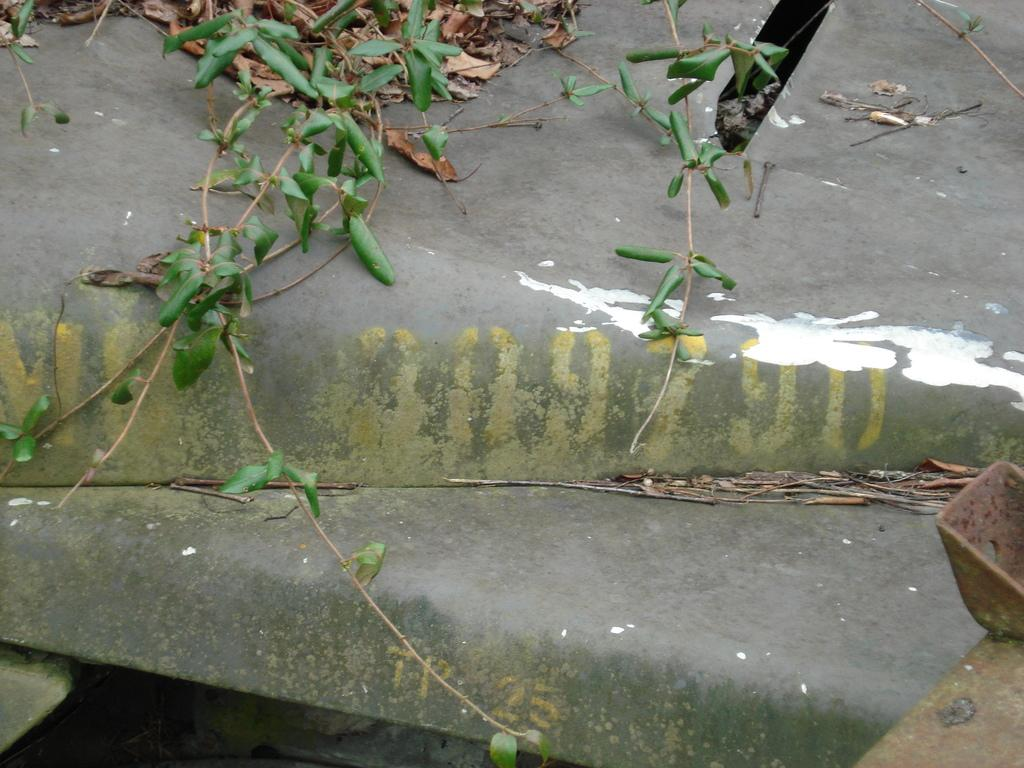What type of living organisms can be seen in the image? Plants can be seen in the image. What part of the plant is visible in the image? Leaves are visible in the image. What type of animal can be seen interacting with the plants in the image? There is no animal present in the image; it only features plants and leaves. What year is depicted in the image? The image does not depict a specific year; it is a still image of plants and leaves. 